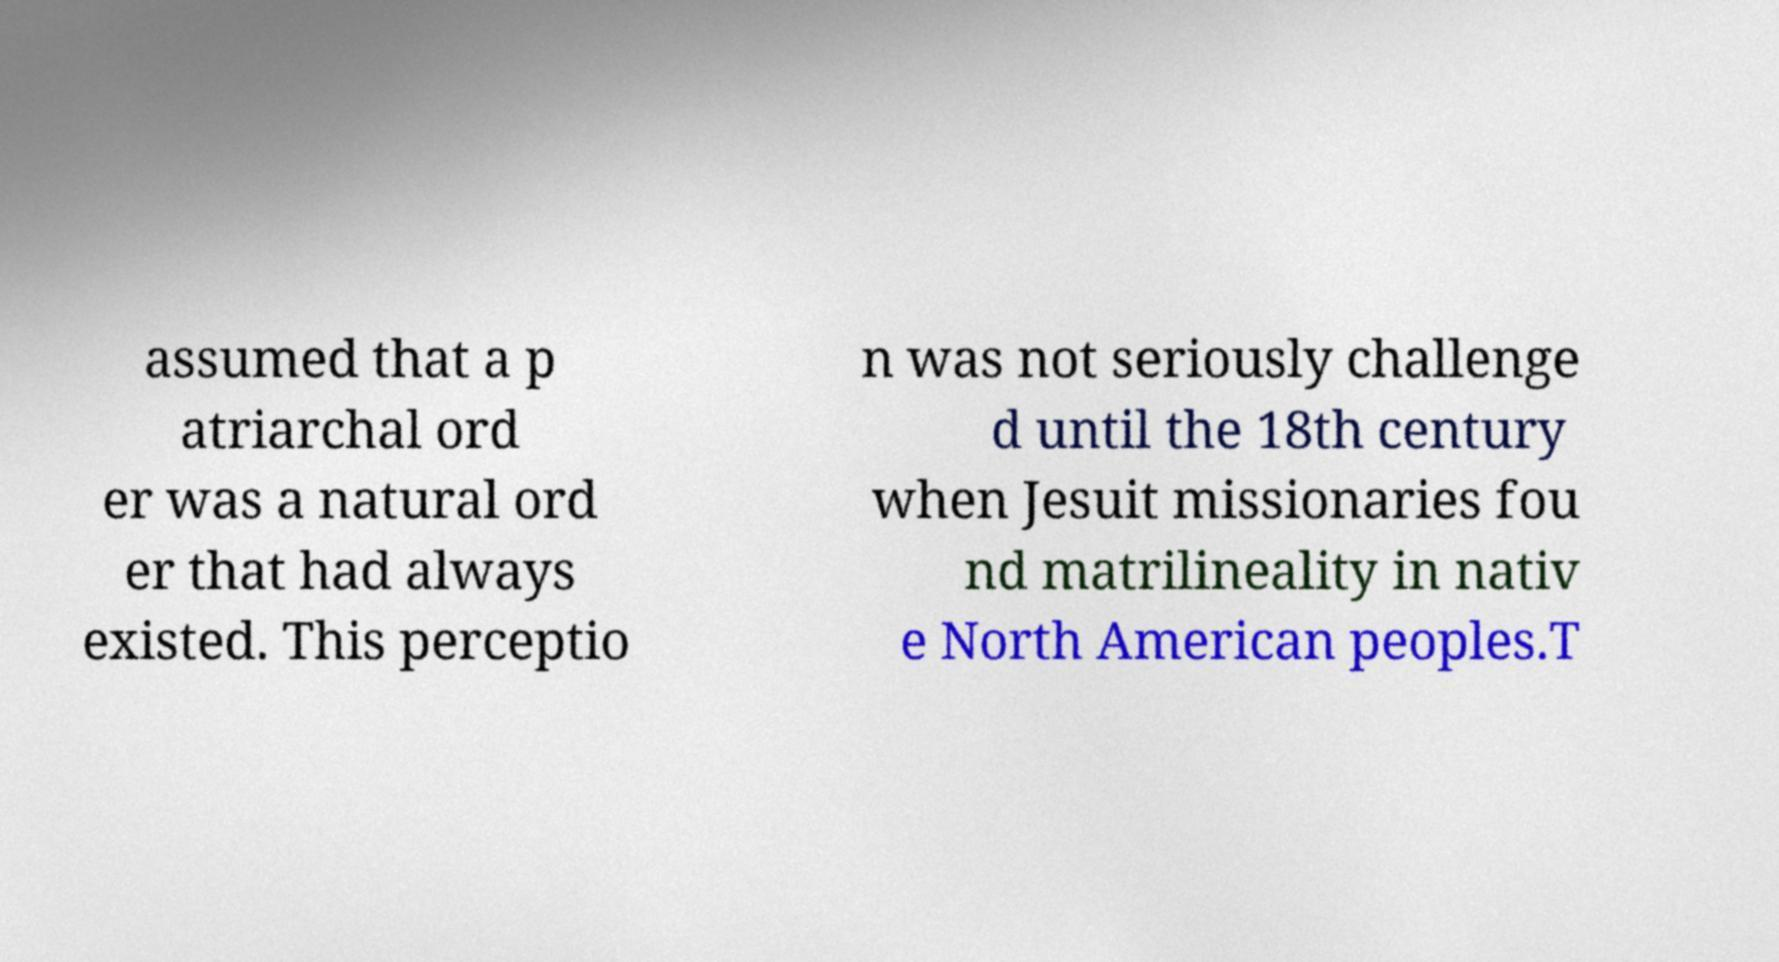Could you extract and type out the text from this image? assumed that a p atriarchal ord er was a natural ord er that had always existed. This perceptio n was not seriously challenge d until the 18th century when Jesuit missionaries fou nd matrilineality in nativ e North American peoples.T 